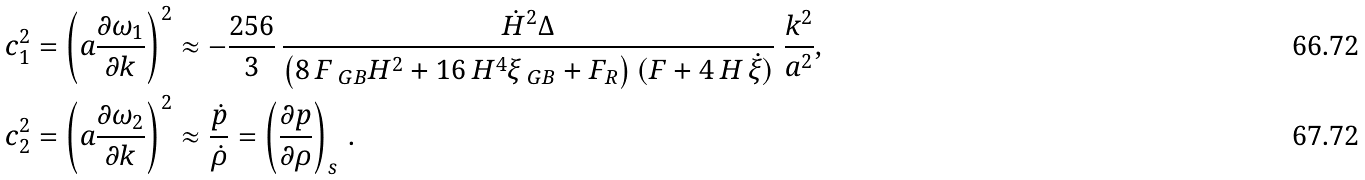Convert formula to latex. <formula><loc_0><loc_0><loc_500><loc_500>c _ { 1 } ^ { 2 } & = { \left ( a \frac { \partial \omega _ { 1 } } { \partial k } \right ) } ^ { 2 } \approx - { \frac { 2 5 6 } { 3 } } \, { \frac { \dot { H } ^ { 2 } \Delta } { \left ( 8 \, F _ { \ G B } H ^ { 2 } + 1 6 \, H ^ { 4 } \xi _ { \ G B } + F _ { R } \right ) ( F + 4 \, H \, \dot { \xi } ) } } \ \frac { k ^ { 2 } } { a ^ { 2 } } , \\ c _ { 2 } ^ { 2 } & = { \left ( a \frac { \partial \omega _ { 2 } } { \partial k } \right ) } ^ { 2 } \approx \frac { \dot { p } } { \dot { \rho } } = \left ( \frac { \partial p } { \partial \rho } \right ) _ { s } \, .</formula> 